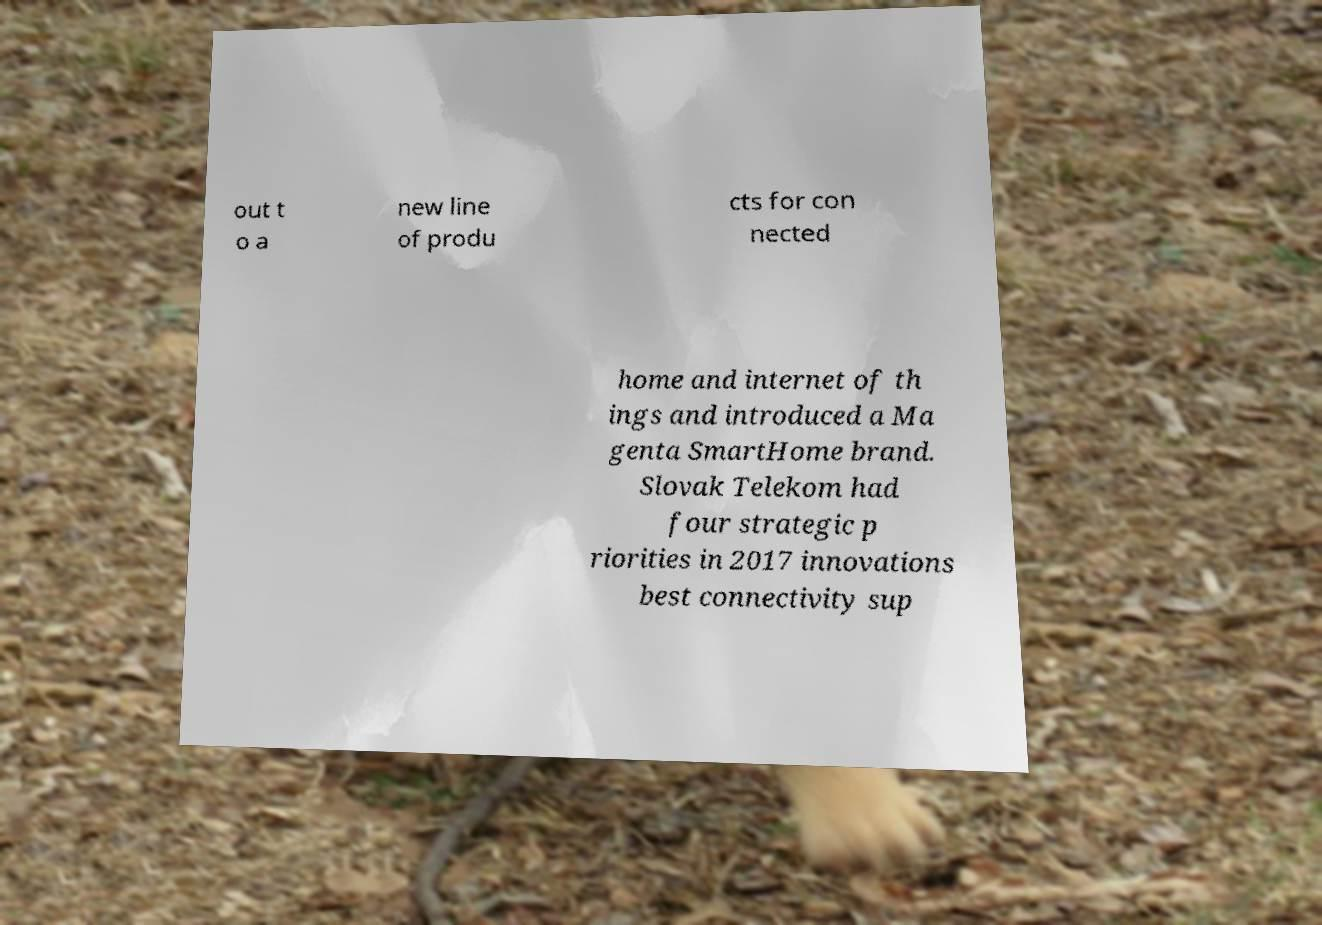Please read and relay the text visible in this image. What does it say? out t o a new line of produ cts for con nected home and internet of th ings and introduced a Ma genta SmartHome brand. Slovak Telekom had four strategic p riorities in 2017 innovations best connectivity sup 